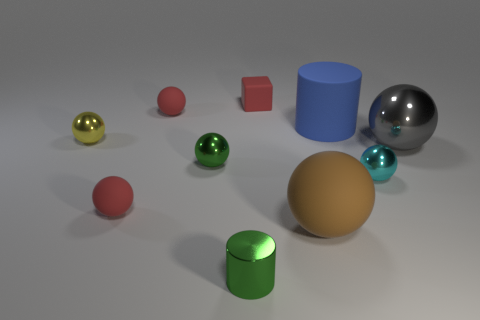The thing that is the same color as the small metal cylinder is what shape?
Your answer should be compact. Sphere. There is a small matte sphere in front of the tiny yellow ball; is it the same color as the matte ball behind the small cyan ball?
Your answer should be very brief. Yes. There is a big cylinder; what number of tiny matte cubes are in front of it?
Keep it short and to the point. 0. The sphere that is the same color as the tiny cylinder is what size?
Your response must be concise. Small. Is there a small yellow metal thing of the same shape as the small cyan thing?
Your answer should be very brief. Yes. There is a cylinder that is the same size as the red block; what color is it?
Offer a terse response. Green. Is the number of small blocks that are to the right of the big rubber ball less than the number of red rubber blocks that are behind the cyan object?
Your answer should be compact. Yes. Is the size of the red thing that is on the right side of the green shiny cylinder the same as the cyan sphere?
Offer a terse response. Yes. What is the shape of the large object that is behind the big gray metal sphere?
Your response must be concise. Cylinder. Are there more matte blocks than tiny purple objects?
Keep it short and to the point. Yes. 